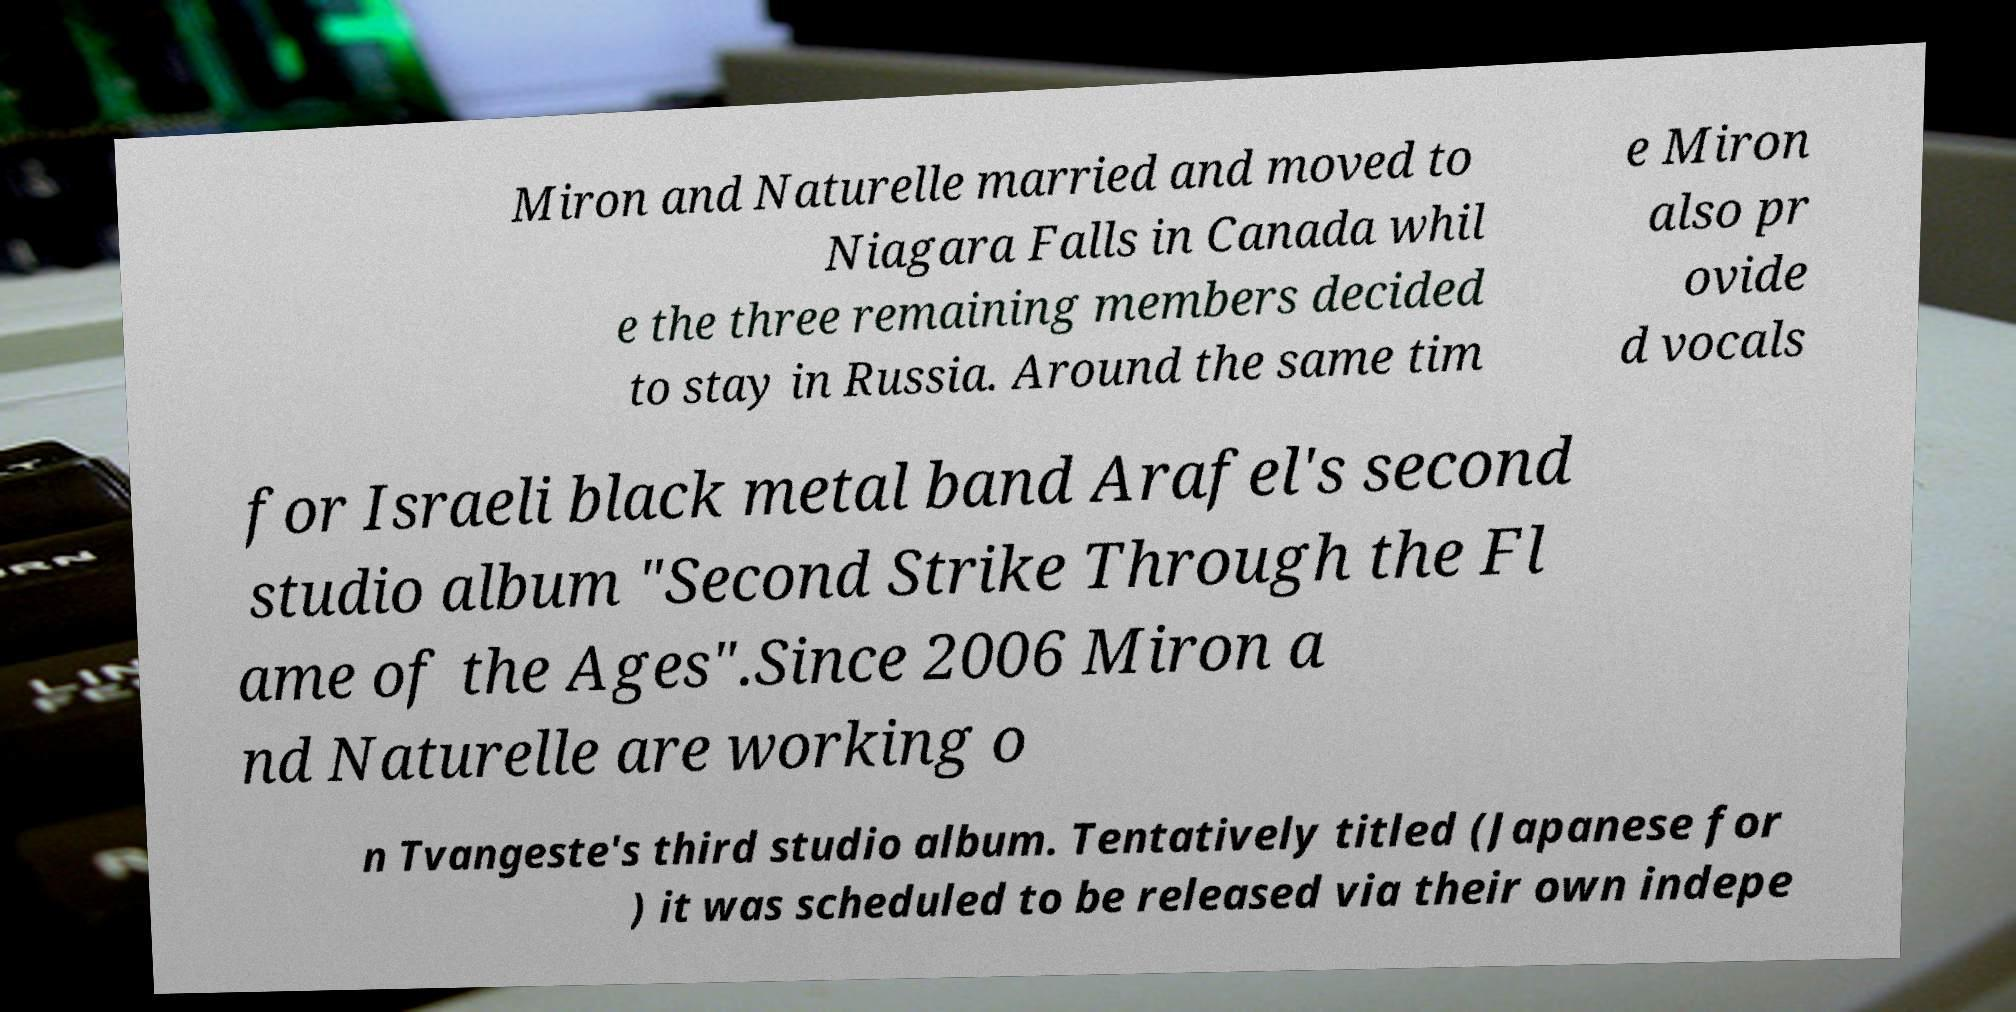Please identify and transcribe the text found in this image. Miron and Naturelle married and moved to Niagara Falls in Canada whil e the three remaining members decided to stay in Russia. Around the same tim e Miron also pr ovide d vocals for Israeli black metal band Arafel's second studio album "Second Strike Through the Fl ame of the Ages".Since 2006 Miron a nd Naturelle are working o n Tvangeste's third studio album. Tentatively titled (Japanese for ) it was scheduled to be released via their own indepe 